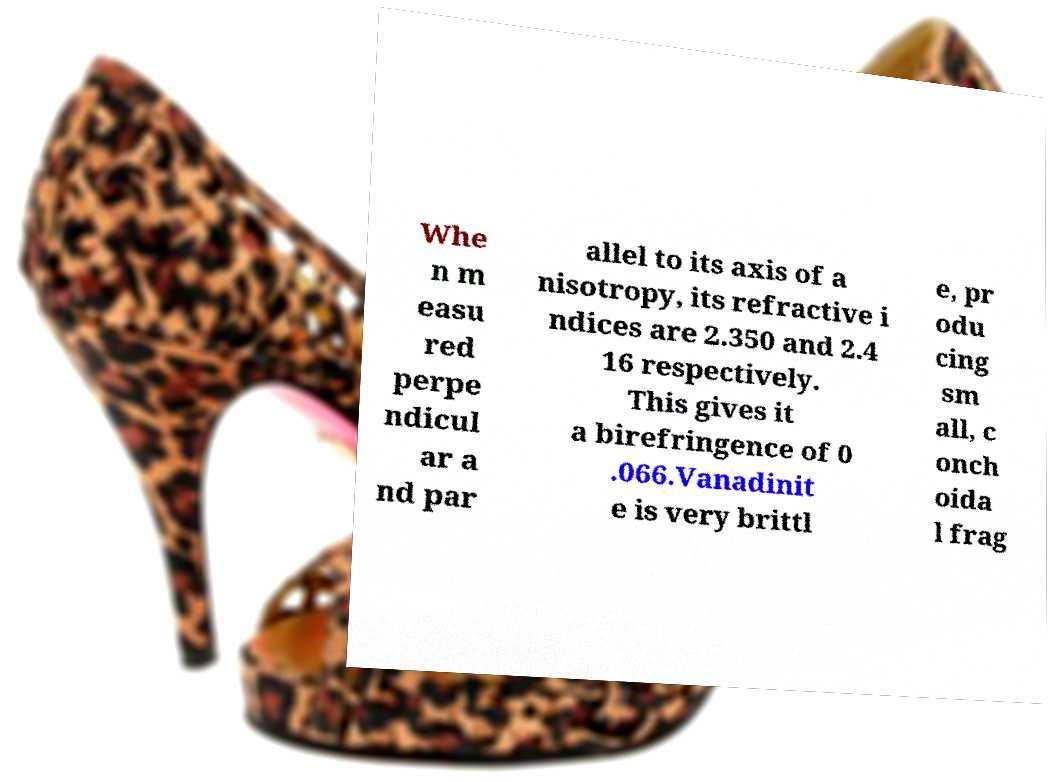Could you extract and type out the text from this image? Whe n m easu red perpe ndicul ar a nd par allel to its axis of a nisotropy, its refractive i ndices are 2.350 and 2.4 16 respectively. This gives it a birefringence of 0 .066.Vanadinit e is very brittl e, pr odu cing sm all, c onch oida l frag 